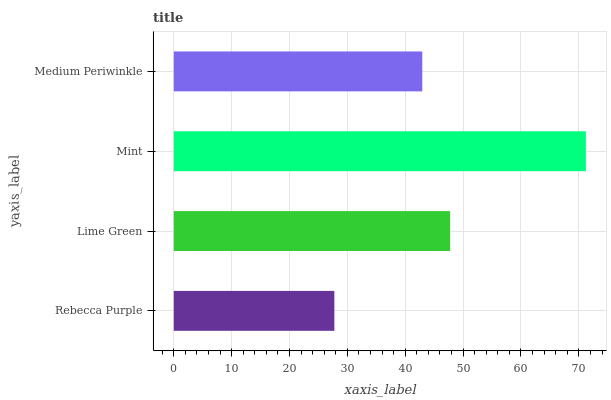Is Rebecca Purple the minimum?
Answer yes or no. Yes. Is Mint the maximum?
Answer yes or no. Yes. Is Lime Green the minimum?
Answer yes or no. No. Is Lime Green the maximum?
Answer yes or no. No. Is Lime Green greater than Rebecca Purple?
Answer yes or no. Yes. Is Rebecca Purple less than Lime Green?
Answer yes or no. Yes. Is Rebecca Purple greater than Lime Green?
Answer yes or no. No. Is Lime Green less than Rebecca Purple?
Answer yes or no. No. Is Lime Green the high median?
Answer yes or no. Yes. Is Medium Periwinkle the low median?
Answer yes or no. Yes. Is Medium Periwinkle the high median?
Answer yes or no. No. Is Mint the low median?
Answer yes or no. No. 